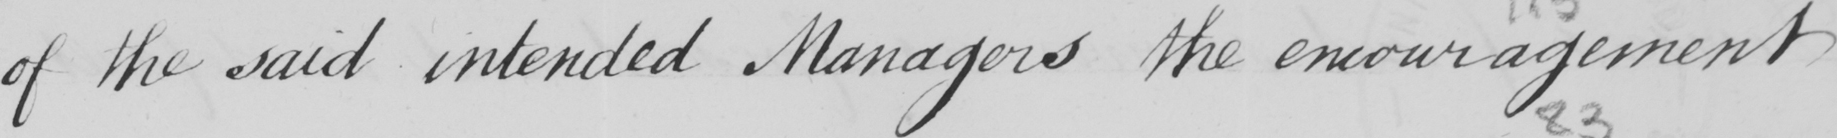Please transcribe the handwritten text in this image. of the said intended Managers the encouragement 